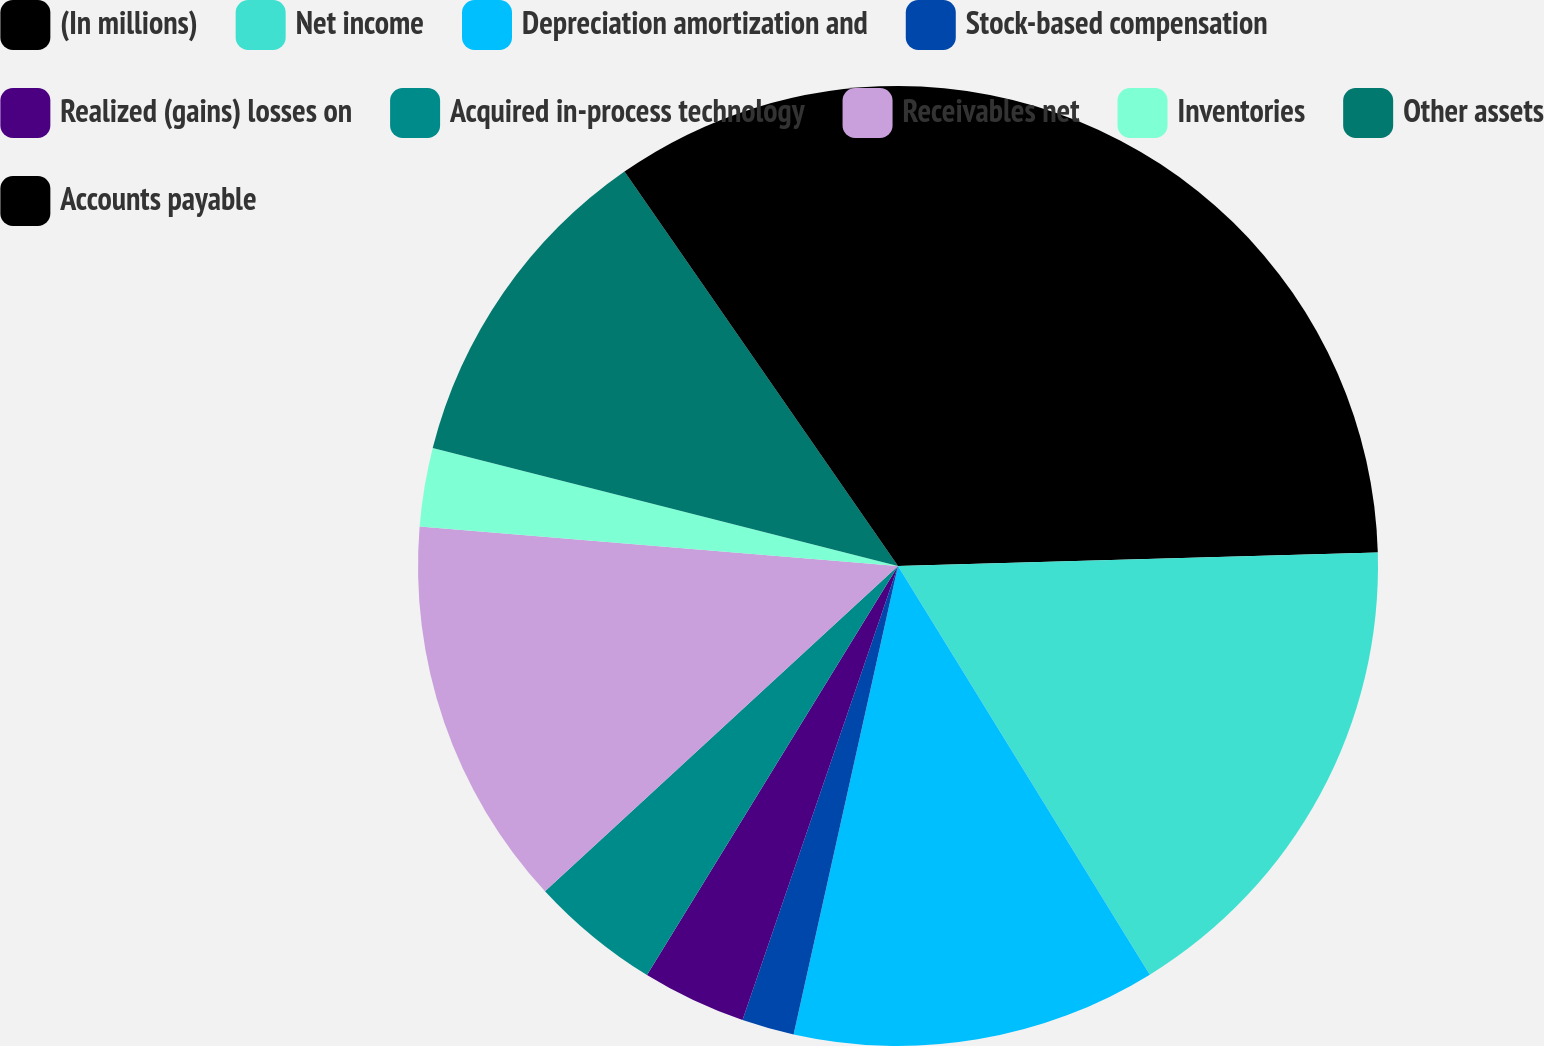Convert chart. <chart><loc_0><loc_0><loc_500><loc_500><pie_chart><fcel>(In millions)<fcel>Net income<fcel>Depreciation amortization and<fcel>Stock-based compensation<fcel>Realized (gains) losses on<fcel>Acquired in-process technology<fcel>Receivables net<fcel>Inventories<fcel>Other assets<fcel>Accounts payable<nl><fcel>24.55%<fcel>16.66%<fcel>12.28%<fcel>1.76%<fcel>3.51%<fcel>4.39%<fcel>13.16%<fcel>2.64%<fcel>11.4%<fcel>9.65%<nl></chart> 